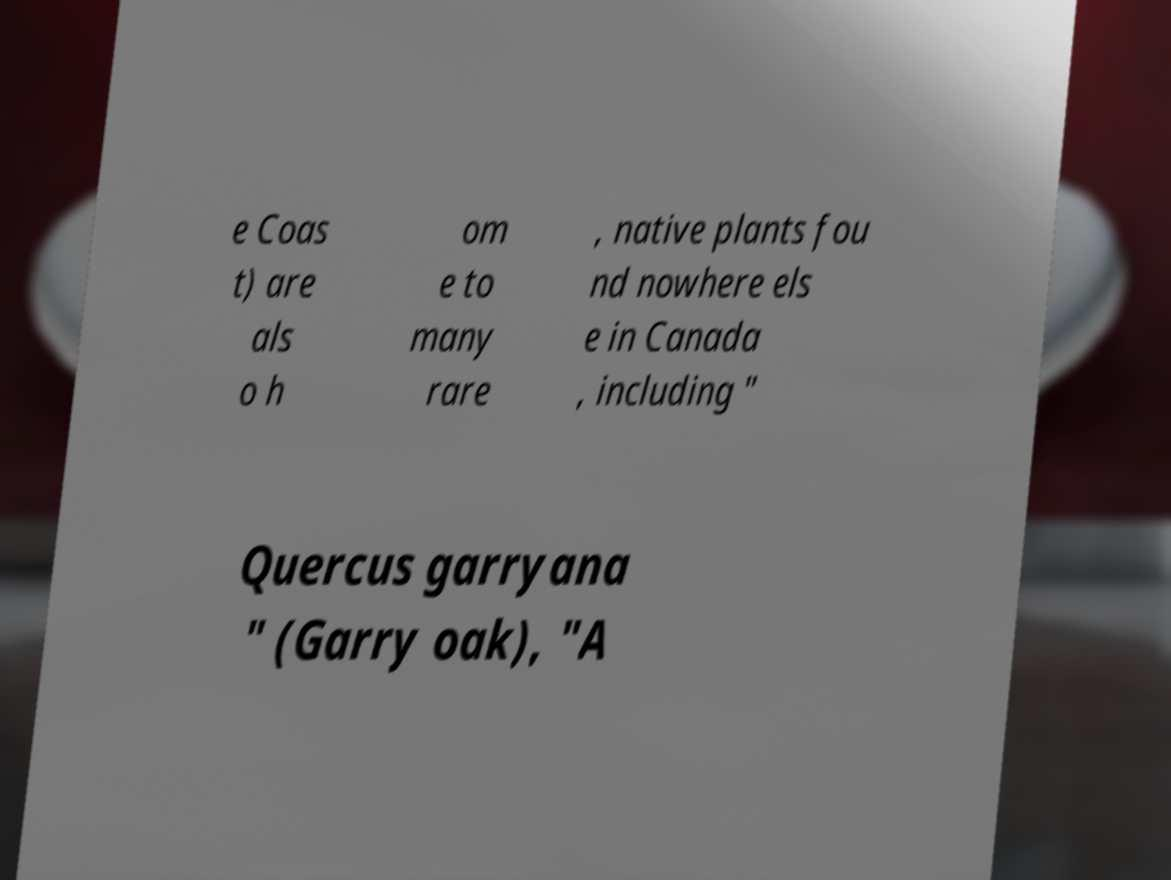There's text embedded in this image that I need extracted. Can you transcribe it verbatim? e Coas t) are als o h om e to many rare , native plants fou nd nowhere els e in Canada , including " Quercus garryana " (Garry oak), "A 